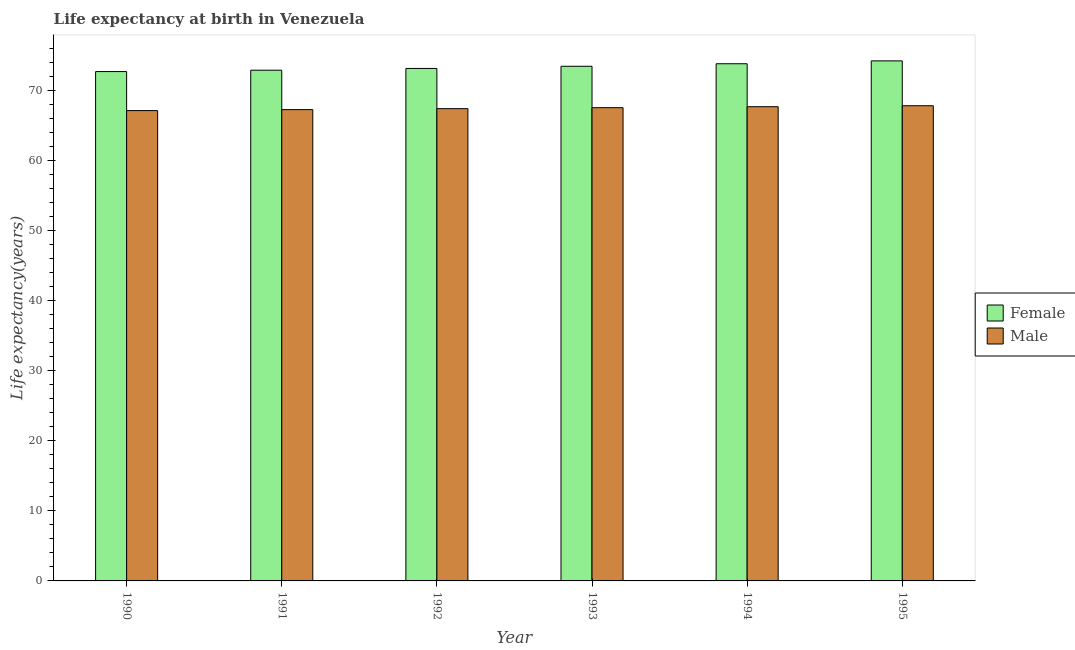Are the number of bars on each tick of the X-axis equal?
Make the answer very short. Yes. How many bars are there on the 5th tick from the right?
Provide a short and direct response. 2. What is the life expectancy(male) in 1993?
Give a very brief answer. 67.53. Across all years, what is the maximum life expectancy(male)?
Ensure brevity in your answer.  67.8. Across all years, what is the minimum life expectancy(female)?
Offer a very short reply. 72.68. In which year was the life expectancy(female) maximum?
Offer a terse response. 1995. What is the total life expectancy(female) in the graph?
Give a very brief answer. 440.12. What is the difference between the life expectancy(male) in 1993 and that in 1995?
Provide a short and direct response. -0.28. What is the difference between the life expectancy(male) in 1990 and the life expectancy(female) in 1994?
Make the answer very short. -0.55. What is the average life expectancy(male) per year?
Make the answer very short. 67.46. In the year 1992, what is the difference between the life expectancy(female) and life expectancy(male)?
Give a very brief answer. 0. What is the ratio of the life expectancy(female) in 1991 to that in 1994?
Provide a short and direct response. 0.99. Is the life expectancy(female) in 1992 less than that in 1995?
Provide a short and direct response. Yes. Is the difference between the life expectancy(female) in 1990 and 1995 greater than the difference between the life expectancy(male) in 1990 and 1995?
Provide a short and direct response. No. What is the difference between the highest and the second highest life expectancy(male)?
Your response must be concise. 0.14. What is the difference between the highest and the lowest life expectancy(female)?
Offer a terse response. 1.53. What does the 1st bar from the left in 1994 represents?
Your response must be concise. Female. Are the values on the major ticks of Y-axis written in scientific E-notation?
Provide a succinct answer. No. Does the graph contain any zero values?
Provide a short and direct response. No. How many legend labels are there?
Provide a succinct answer. 2. What is the title of the graph?
Provide a short and direct response. Life expectancy at birth in Venezuela. What is the label or title of the Y-axis?
Offer a terse response. Life expectancy(years). What is the Life expectancy(years) in Female in 1990?
Your answer should be compact. 72.68. What is the Life expectancy(years) in Male in 1990?
Offer a very short reply. 67.11. What is the Life expectancy(years) in Female in 1991?
Keep it short and to the point. 72.88. What is the Life expectancy(years) in Male in 1991?
Offer a very short reply. 67.25. What is the Life expectancy(years) of Female in 1992?
Provide a short and direct response. 73.13. What is the Life expectancy(years) of Male in 1992?
Ensure brevity in your answer.  67.39. What is the Life expectancy(years) in Female in 1993?
Give a very brief answer. 73.44. What is the Life expectancy(years) in Male in 1993?
Offer a very short reply. 67.53. What is the Life expectancy(years) of Female in 1994?
Give a very brief answer. 73.8. What is the Life expectancy(years) in Male in 1994?
Offer a terse response. 67.67. What is the Life expectancy(years) in Female in 1995?
Give a very brief answer. 74.21. What is the Life expectancy(years) in Male in 1995?
Provide a short and direct response. 67.8. Across all years, what is the maximum Life expectancy(years) of Female?
Make the answer very short. 74.21. Across all years, what is the maximum Life expectancy(years) of Male?
Provide a succinct answer. 67.8. Across all years, what is the minimum Life expectancy(years) of Female?
Ensure brevity in your answer.  72.68. Across all years, what is the minimum Life expectancy(years) in Male?
Offer a terse response. 67.11. What is the total Life expectancy(years) of Female in the graph?
Your response must be concise. 440.12. What is the total Life expectancy(years) in Male in the graph?
Provide a short and direct response. 404.75. What is the difference between the Life expectancy(years) in Female in 1990 and that in 1991?
Ensure brevity in your answer.  -0.2. What is the difference between the Life expectancy(years) in Male in 1990 and that in 1991?
Your response must be concise. -0.14. What is the difference between the Life expectancy(years) in Female in 1990 and that in 1992?
Ensure brevity in your answer.  -0.45. What is the difference between the Life expectancy(years) of Male in 1990 and that in 1992?
Your answer should be compact. -0.28. What is the difference between the Life expectancy(years) of Female in 1990 and that in 1993?
Provide a short and direct response. -0.76. What is the difference between the Life expectancy(years) in Male in 1990 and that in 1993?
Ensure brevity in your answer.  -0.41. What is the difference between the Life expectancy(years) in Female in 1990 and that in 1994?
Offer a terse response. -1.12. What is the difference between the Life expectancy(years) in Male in 1990 and that in 1994?
Offer a very short reply. -0.55. What is the difference between the Life expectancy(years) of Female in 1990 and that in 1995?
Make the answer very short. -1.53. What is the difference between the Life expectancy(years) of Male in 1990 and that in 1995?
Your answer should be compact. -0.69. What is the difference between the Life expectancy(years) of Female in 1991 and that in 1992?
Your answer should be very brief. -0.25. What is the difference between the Life expectancy(years) of Male in 1991 and that in 1992?
Ensure brevity in your answer.  -0.14. What is the difference between the Life expectancy(years) in Female in 1991 and that in 1993?
Offer a very short reply. -0.56. What is the difference between the Life expectancy(years) of Male in 1991 and that in 1993?
Your response must be concise. -0.28. What is the difference between the Life expectancy(years) of Female in 1991 and that in 1994?
Ensure brevity in your answer.  -0.92. What is the difference between the Life expectancy(years) of Male in 1991 and that in 1994?
Provide a short and direct response. -0.41. What is the difference between the Life expectancy(years) of Female in 1991 and that in 1995?
Your answer should be compact. -1.33. What is the difference between the Life expectancy(years) of Male in 1991 and that in 1995?
Offer a very short reply. -0.55. What is the difference between the Life expectancy(years) of Female in 1992 and that in 1993?
Keep it short and to the point. -0.31. What is the difference between the Life expectancy(years) of Male in 1992 and that in 1993?
Ensure brevity in your answer.  -0.14. What is the difference between the Life expectancy(years) of Female in 1992 and that in 1994?
Offer a terse response. -0.67. What is the difference between the Life expectancy(years) in Male in 1992 and that in 1994?
Provide a succinct answer. -0.28. What is the difference between the Life expectancy(years) in Female in 1992 and that in 1995?
Your response must be concise. -1.08. What is the difference between the Life expectancy(years) in Male in 1992 and that in 1995?
Your response must be concise. -0.41. What is the difference between the Life expectancy(years) in Female in 1993 and that in 1994?
Make the answer very short. -0.36. What is the difference between the Life expectancy(years) of Male in 1993 and that in 1994?
Your response must be concise. -0.14. What is the difference between the Life expectancy(years) in Female in 1993 and that in 1995?
Give a very brief answer. -0.77. What is the difference between the Life expectancy(years) in Male in 1993 and that in 1995?
Make the answer very short. -0.28. What is the difference between the Life expectancy(years) of Female in 1994 and that in 1995?
Your answer should be very brief. -0.41. What is the difference between the Life expectancy(years) of Male in 1994 and that in 1995?
Your answer should be compact. -0.14. What is the difference between the Life expectancy(years) of Female in 1990 and the Life expectancy(years) of Male in 1991?
Give a very brief answer. 5.43. What is the difference between the Life expectancy(years) in Female in 1990 and the Life expectancy(years) in Male in 1992?
Make the answer very short. 5.29. What is the difference between the Life expectancy(years) in Female in 1990 and the Life expectancy(years) in Male in 1993?
Offer a terse response. 5.15. What is the difference between the Life expectancy(years) of Female in 1990 and the Life expectancy(years) of Male in 1994?
Your response must be concise. 5.01. What is the difference between the Life expectancy(years) of Female in 1990 and the Life expectancy(years) of Male in 1995?
Provide a succinct answer. 4.88. What is the difference between the Life expectancy(years) in Female in 1991 and the Life expectancy(years) in Male in 1992?
Offer a terse response. 5.49. What is the difference between the Life expectancy(years) of Female in 1991 and the Life expectancy(years) of Male in 1993?
Ensure brevity in your answer.  5.35. What is the difference between the Life expectancy(years) of Female in 1991 and the Life expectancy(years) of Male in 1994?
Give a very brief answer. 5.21. What is the difference between the Life expectancy(years) in Female in 1991 and the Life expectancy(years) in Male in 1995?
Your response must be concise. 5.07. What is the difference between the Life expectancy(years) of Female in 1992 and the Life expectancy(years) of Male in 1994?
Make the answer very short. 5.46. What is the difference between the Life expectancy(years) in Female in 1992 and the Life expectancy(years) in Male in 1995?
Provide a succinct answer. 5.32. What is the difference between the Life expectancy(years) in Female in 1993 and the Life expectancy(years) in Male in 1994?
Your answer should be very brief. 5.77. What is the difference between the Life expectancy(years) of Female in 1993 and the Life expectancy(years) of Male in 1995?
Offer a very short reply. 5.63. What is the difference between the Life expectancy(years) of Female in 1994 and the Life expectancy(years) of Male in 1995?
Your answer should be very brief. 5.99. What is the average Life expectancy(years) in Female per year?
Your answer should be very brief. 73.35. What is the average Life expectancy(years) in Male per year?
Your answer should be very brief. 67.46. In the year 1990, what is the difference between the Life expectancy(years) in Female and Life expectancy(years) in Male?
Give a very brief answer. 5.57. In the year 1991, what is the difference between the Life expectancy(years) in Female and Life expectancy(years) in Male?
Offer a terse response. 5.62. In the year 1992, what is the difference between the Life expectancy(years) in Female and Life expectancy(years) in Male?
Your response must be concise. 5.74. In the year 1993, what is the difference between the Life expectancy(years) in Female and Life expectancy(years) in Male?
Provide a short and direct response. 5.91. In the year 1994, what is the difference between the Life expectancy(years) of Female and Life expectancy(years) of Male?
Your answer should be very brief. 6.13. In the year 1995, what is the difference between the Life expectancy(years) in Female and Life expectancy(years) in Male?
Offer a terse response. 6.4. What is the ratio of the Life expectancy(years) in Female in 1990 to that in 1991?
Provide a succinct answer. 1. What is the ratio of the Life expectancy(years) in Male in 1990 to that in 1992?
Your response must be concise. 1. What is the ratio of the Life expectancy(years) in Female in 1990 to that in 1993?
Provide a short and direct response. 0.99. What is the ratio of the Life expectancy(years) in Male in 1990 to that in 1993?
Your answer should be compact. 0.99. What is the ratio of the Life expectancy(years) of Female in 1990 to that in 1994?
Your answer should be very brief. 0.98. What is the ratio of the Life expectancy(years) of Female in 1990 to that in 1995?
Provide a short and direct response. 0.98. What is the ratio of the Life expectancy(years) in Male in 1990 to that in 1995?
Your answer should be very brief. 0.99. What is the ratio of the Life expectancy(years) of Female in 1991 to that in 1992?
Make the answer very short. 1. What is the ratio of the Life expectancy(years) of Male in 1991 to that in 1992?
Your answer should be very brief. 1. What is the ratio of the Life expectancy(years) in Female in 1991 to that in 1993?
Provide a short and direct response. 0.99. What is the ratio of the Life expectancy(years) in Female in 1991 to that in 1994?
Your answer should be compact. 0.99. What is the ratio of the Life expectancy(years) in Male in 1991 to that in 1994?
Keep it short and to the point. 0.99. What is the ratio of the Life expectancy(years) in Female in 1991 to that in 1995?
Your answer should be compact. 0.98. What is the ratio of the Life expectancy(years) of Male in 1991 to that in 1995?
Your response must be concise. 0.99. What is the ratio of the Life expectancy(years) of Female in 1992 to that in 1994?
Offer a terse response. 0.99. What is the ratio of the Life expectancy(years) in Male in 1992 to that in 1994?
Provide a short and direct response. 1. What is the ratio of the Life expectancy(years) in Female in 1992 to that in 1995?
Give a very brief answer. 0.99. What is the ratio of the Life expectancy(years) in Male in 1992 to that in 1995?
Give a very brief answer. 0.99. What is the ratio of the Life expectancy(years) in Female in 1993 to that in 1994?
Offer a very short reply. 1. What is the ratio of the Life expectancy(years) of Male in 1993 to that in 1994?
Offer a terse response. 1. What is the ratio of the Life expectancy(years) in Female in 1994 to that in 1995?
Offer a terse response. 0.99. What is the ratio of the Life expectancy(years) in Male in 1994 to that in 1995?
Provide a succinct answer. 1. What is the difference between the highest and the second highest Life expectancy(years) in Female?
Provide a succinct answer. 0.41. What is the difference between the highest and the second highest Life expectancy(years) in Male?
Make the answer very short. 0.14. What is the difference between the highest and the lowest Life expectancy(years) of Female?
Offer a terse response. 1.53. What is the difference between the highest and the lowest Life expectancy(years) in Male?
Offer a terse response. 0.69. 